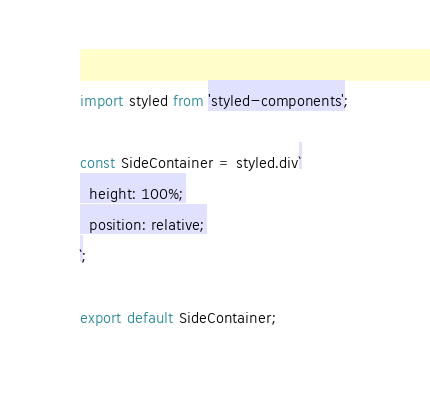<code> <loc_0><loc_0><loc_500><loc_500><_TypeScript_>import styled from 'styled-components';

const SideContainer = styled.div`
  height: 100%;
  position: relative;
`;

export default SideContainer;
</code> 